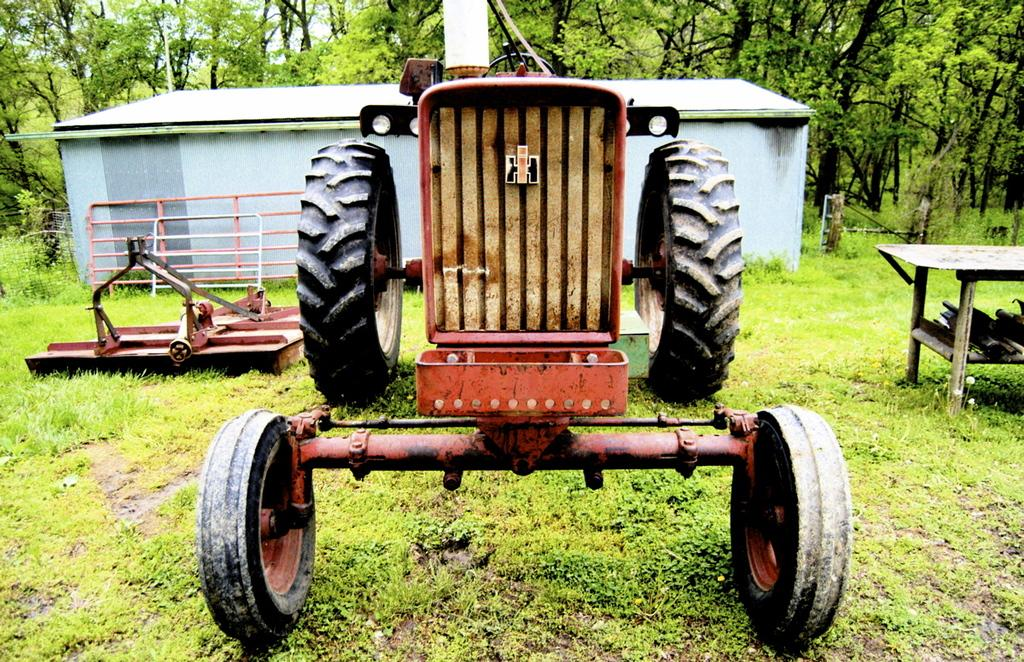What is the main subject in the image? There is a vehicle in the image. What else can be seen on the right side of the image? There is a table on the right side of the image. What is visible in the background of the image? There is a shed and trees in the background of the image. Is there a cook preparing a meal in the shed in the image? There is no cook or any indication of food preparation in the shed or the image. 